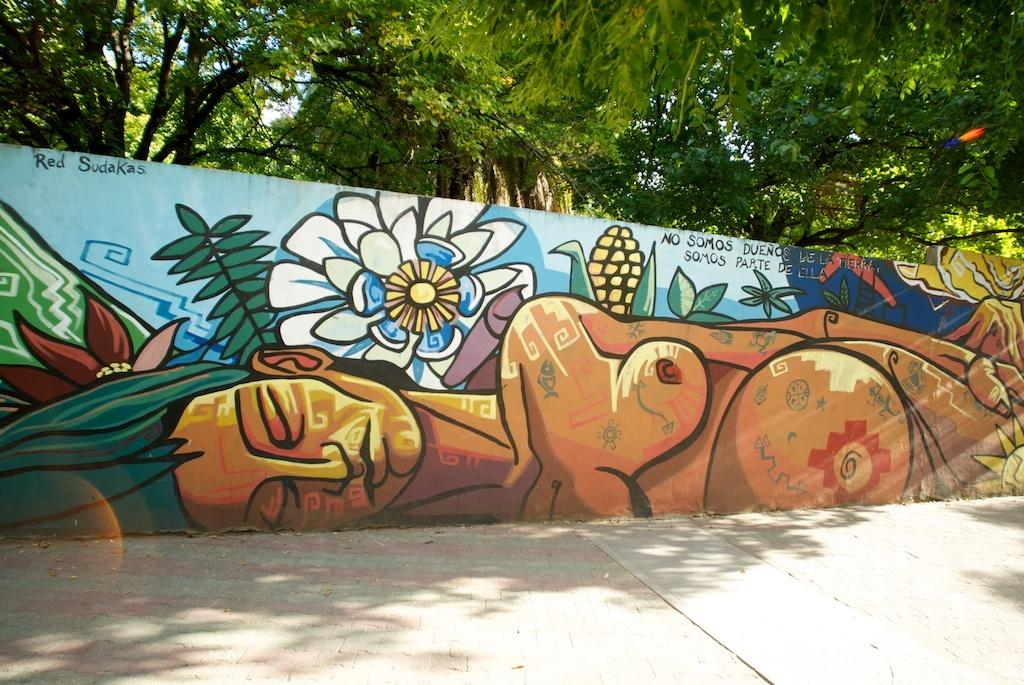What is depicted on the wall in the image? There is a wall with paintings and text in the image. What can be seen in the background of the image? There are trees and the sky visible in the background of the image. What is at the bottom of the image? There is a floor at the bottom of the image. How many pears are lying on the floor in the image? There are no pears present in the image; the floor is the only element mentioned at the bottom of the image. 